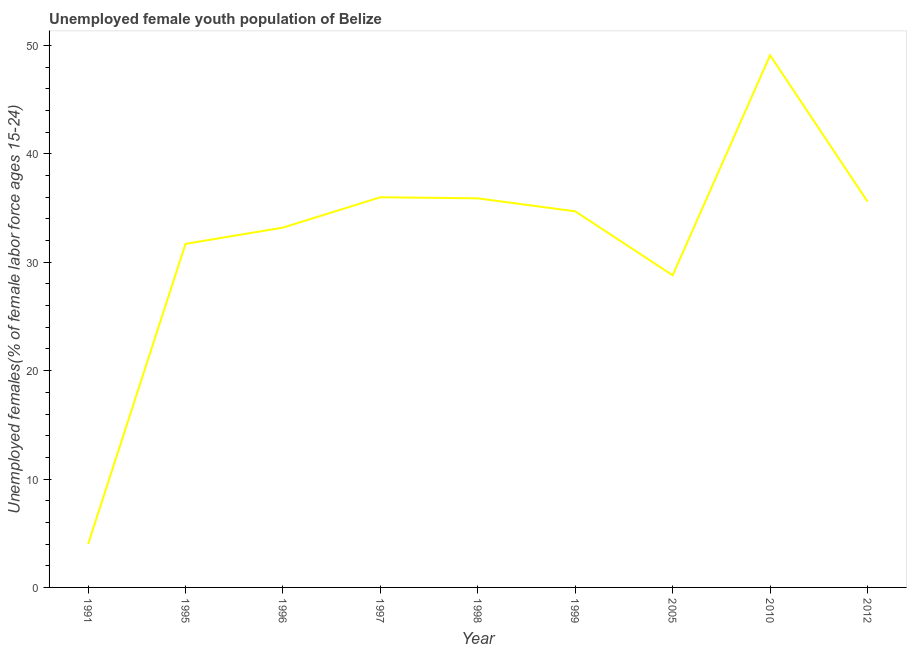What is the unemployed female youth in 1999?
Ensure brevity in your answer.  34.7. Across all years, what is the maximum unemployed female youth?
Keep it short and to the point. 49.1. What is the sum of the unemployed female youth?
Offer a very short reply. 289. What is the difference between the unemployed female youth in 1991 and 1999?
Provide a short and direct response. -30.7. What is the average unemployed female youth per year?
Offer a very short reply. 32.11. What is the median unemployed female youth?
Provide a succinct answer. 34.7. Do a majority of the years between 1998 and 2005 (inclusive) have unemployed female youth greater than 26 %?
Your response must be concise. Yes. What is the ratio of the unemployed female youth in 1996 to that in 1997?
Provide a succinct answer. 0.92. Is the unemployed female youth in 1996 less than that in 2005?
Your response must be concise. No. Is the difference between the unemployed female youth in 1995 and 1996 greater than the difference between any two years?
Give a very brief answer. No. What is the difference between the highest and the second highest unemployed female youth?
Ensure brevity in your answer.  13.1. What is the difference between the highest and the lowest unemployed female youth?
Your answer should be compact. 45.1. In how many years, is the unemployed female youth greater than the average unemployed female youth taken over all years?
Offer a terse response. 6. Does the unemployed female youth monotonically increase over the years?
Your answer should be compact. No. How many years are there in the graph?
Your response must be concise. 9. What is the difference between two consecutive major ticks on the Y-axis?
Your answer should be very brief. 10. What is the title of the graph?
Give a very brief answer. Unemployed female youth population of Belize. What is the label or title of the X-axis?
Your answer should be compact. Year. What is the label or title of the Y-axis?
Your answer should be compact. Unemployed females(% of female labor force ages 15-24). What is the Unemployed females(% of female labor force ages 15-24) in 1991?
Your response must be concise. 4. What is the Unemployed females(% of female labor force ages 15-24) in 1995?
Ensure brevity in your answer.  31.7. What is the Unemployed females(% of female labor force ages 15-24) of 1996?
Your response must be concise. 33.2. What is the Unemployed females(% of female labor force ages 15-24) of 1998?
Give a very brief answer. 35.9. What is the Unemployed females(% of female labor force ages 15-24) of 1999?
Offer a very short reply. 34.7. What is the Unemployed females(% of female labor force ages 15-24) of 2005?
Keep it short and to the point. 28.8. What is the Unemployed females(% of female labor force ages 15-24) of 2010?
Make the answer very short. 49.1. What is the Unemployed females(% of female labor force ages 15-24) in 2012?
Offer a very short reply. 35.6. What is the difference between the Unemployed females(% of female labor force ages 15-24) in 1991 and 1995?
Your response must be concise. -27.7. What is the difference between the Unemployed females(% of female labor force ages 15-24) in 1991 and 1996?
Offer a very short reply. -29.2. What is the difference between the Unemployed females(% of female labor force ages 15-24) in 1991 and 1997?
Ensure brevity in your answer.  -32. What is the difference between the Unemployed females(% of female labor force ages 15-24) in 1991 and 1998?
Keep it short and to the point. -31.9. What is the difference between the Unemployed females(% of female labor force ages 15-24) in 1991 and 1999?
Give a very brief answer. -30.7. What is the difference between the Unemployed females(% of female labor force ages 15-24) in 1991 and 2005?
Provide a short and direct response. -24.8. What is the difference between the Unemployed females(% of female labor force ages 15-24) in 1991 and 2010?
Make the answer very short. -45.1. What is the difference between the Unemployed females(% of female labor force ages 15-24) in 1991 and 2012?
Your response must be concise. -31.6. What is the difference between the Unemployed females(% of female labor force ages 15-24) in 1995 and 1997?
Make the answer very short. -4.3. What is the difference between the Unemployed females(% of female labor force ages 15-24) in 1995 and 1999?
Your answer should be compact. -3. What is the difference between the Unemployed females(% of female labor force ages 15-24) in 1995 and 2005?
Your answer should be compact. 2.9. What is the difference between the Unemployed females(% of female labor force ages 15-24) in 1995 and 2010?
Keep it short and to the point. -17.4. What is the difference between the Unemployed females(% of female labor force ages 15-24) in 1995 and 2012?
Offer a very short reply. -3.9. What is the difference between the Unemployed females(% of female labor force ages 15-24) in 1996 and 1997?
Make the answer very short. -2.8. What is the difference between the Unemployed females(% of female labor force ages 15-24) in 1996 and 1998?
Your answer should be compact. -2.7. What is the difference between the Unemployed females(% of female labor force ages 15-24) in 1996 and 1999?
Your response must be concise. -1.5. What is the difference between the Unemployed females(% of female labor force ages 15-24) in 1996 and 2005?
Your answer should be compact. 4.4. What is the difference between the Unemployed females(% of female labor force ages 15-24) in 1996 and 2010?
Provide a succinct answer. -15.9. What is the difference between the Unemployed females(% of female labor force ages 15-24) in 1997 and 1998?
Offer a very short reply. 0.1. What is the difference between the Unemployed females(% of female labor force ages 15-24) in 1997 and 2010?
Provide a succinct answer. -13.1. What is the difference between the Unemployed females(% of female labor force ages 15-24) in 1997 and 2012?
Offer a terse response. 0.4. What is the difference between the Unemployed females(% of female labor force ages 15-24) in 1998 and 2005?
Keep it short and to the point. 7.1. What is the difference between the Unemployed females(% of female labor force ages 15-24) in 1999 and 2005?
Offer a very short reply. 5.9. What is the difference between the Unemployed females(% of female labor force ages 15-24) in 1999 and 2010?
Ensure brevity in your answer.  -14.4. What is the difference between the Unemployed females(% of female labor force ages 15-24) in 2005 and 2010?
Offer a terse response. -20.3. What is the difference between the Unemployed females(% of female labor force ages 15-24) in 2005 and 2012?
Make the answer very short. -6.8. What is the ratio of the Unemployed females(% of female labor force ages 15-24) in 1991 to that in 1995?
Your answer should be very brief. 0.13. What is the ratio of the Unemployed females(% of female labor force ages 15-24) in 1991 to that in 1996?
Provide a short and direct response. 0.12. What is the ratio of the Unemployed females(% of female labor force ages 15-24) in 1991 to that in 1997?
Provide a short and direct response. 0.11. What is the ratio of the Unemployed females(% of female labor force ages 15-24) in 1991 to that in 1998?
Your answer should be very brief. 0.11. What is the ratio of the Unemployed females(% of female labor force ages 15-24) in 1991 to that in 1999?
Offer a very short reply. 0.12. What is the ratio of the Unemployed females(% of female labor force ages 15-24) in 1991 to that in 2005?
Provide a short and direct response. 0.14. What is the ratio of the Unemployed females(% of female labor force ages 15-24) in 1991 to that in 2010?
Offer a terse response. 0.08. What is the ratio of the Unemployed females(% of female labor force ages 15-24) in 1991 to that in 2012?
Keep it short and to the point. 0.11. What is the ratio of the Unemployed females(% of female labor force ages 15-24) in 1995 to that in 1996?
Your answer should be compact. 0.95. What is the ratio of the Unemployed females(% of female labor force ages 15-24) in 1995 to that in 1997?
Make the answer very short. 0.88. What is the ratio of the Unemployed females(% of female labor force ages 15-24) in 1995 to that in 1998?
Keep it short and to the point. 0.88. What is the ratio of the Unemployed females(% of female labor force ages 15-24) in 1995 to that in 1999?
Offer a terse response. 0.91. What is the ratio of the Unemployed females(% of female labor force ages 15-24) in 1995 to that in 2005?
Provide a succinct answer. 1.1. What is the ratio of the Unemployed females(% of female labor force ages 15-24) in 1995 to that in 2010?
Keep it short and to the point. 0.65. What is the ratio of the Unemployed females(% of female labor force ages 15-24) in 1995 to that in 2012?
Keep it short and to the point. 0.89. What is the ratio of the Unemployed females(% of female labor force ages 15-24) in 1996 to that in 1997?
Make the answer very short. 0.92. What is the ratio of the Unemployed females(% of female labor force ages 15-24) in 1996 to that in 1998?
Your answer should be very brief. 0.93. What is the ratio of the Unemployed females(% of female labor force ages 15-24) in 1996 to that in 1999?
Give a very brief answer. 0.96. What is the ratio of the Unemployed females(% of female labor force ages 15-24) in 1996 to that in 2005?
Your answer should be very brief. 1.15. What is the ratio of the Unemployed females(% of female labor force ages 15-24) in 1996 to that in 2010?
Your response must be concise. 0.68. What is the ratio of the Unemployed females(% of female labor force ages 15-24) in 1996 to that in 2012?
Make the answer very short. 0.93. What is the ratio of the Unemployed females(% of female labor force ages 15-24) in 1997 to that in 1998?
Keep it short and to the point. 1. What is the ratio of the Unemployed females(% of female labor force ages 15-24) in 1997 to that in 1999?
Keep it short and to the point. 1.04. What is the ratio of the Unemployed females(% of female labor force ages 15-24) in 1997 to that in 2005?
Offer a terse response. 1.25. What is the ratio of the Unemployed females(% of female labor force ages 15-24) in 1997 to that in 2010?
Ensure brevity in your answer.  0.73. What is the ratio of the Unemployed females(% of female labor force ages 15-24) in 1998 to that in 1999?
Offer a terse response. 1.03. What is the ratio of the Unemployed females(% of female labor force ages 15-24) in 1998 to that in 2005?
Your answer should be compact. 1.25. What is the ratio of the Unemployed females(% of female labor force ages 15-24) in 1998 to that in 2010?
Give a very brief answer. 0.73. What is the ratio of the Unemployed females(% of female labor force ages 15-24) in 1998 to that in 2012?
Keep it short and to the point. 1.01. What is the ratio of the Unemployed females(% of female labor force ages 15-24) in 1999 to that in 2005?
Your answer should be very brief. 1.21. What is the ratio of the Unemployed females(% of female labor force ages 15-24) in 1999 to that in 2010?
Your response must be concise. 0.71. What is the ratio of the Unemployed females(% of female labor force ages 15-24) in 2005 to that in 2010?
Your answer should be compact. 0.59. What is the ratio of the Unemployed females(% of female labor force ages 15-24) in 2005 to that in 2012?
Give a very brief answer. 0.81. What is the ratio of the Unemployed females(% of female labor force ages 15-24) in 2010 to that in 2012?
Provide a short and direct response. 1.38. 